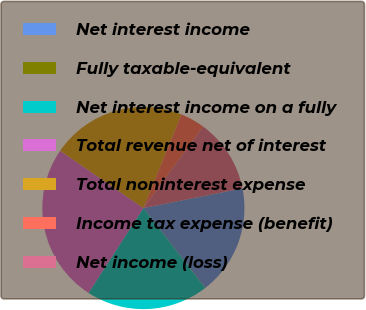<chart> <loc_0><loc_0><loc_500><loc_500><pie_chart><fcel>Net interest income<fcel>Fully taxable-equivalent<fcel>Net interest income on a fully<fcel>Total revenue net of interest<fcel>Total noninterest expense<fcel>Income tax expense (benefit)<fcel>Net income (loss)<nl><fcel>17.64%<fcel>0.03%<fcel>19.6%<fcel>25.47%<fcel>21.56%<fcel>3.94%<fcel>11.77%<nl></chart> 